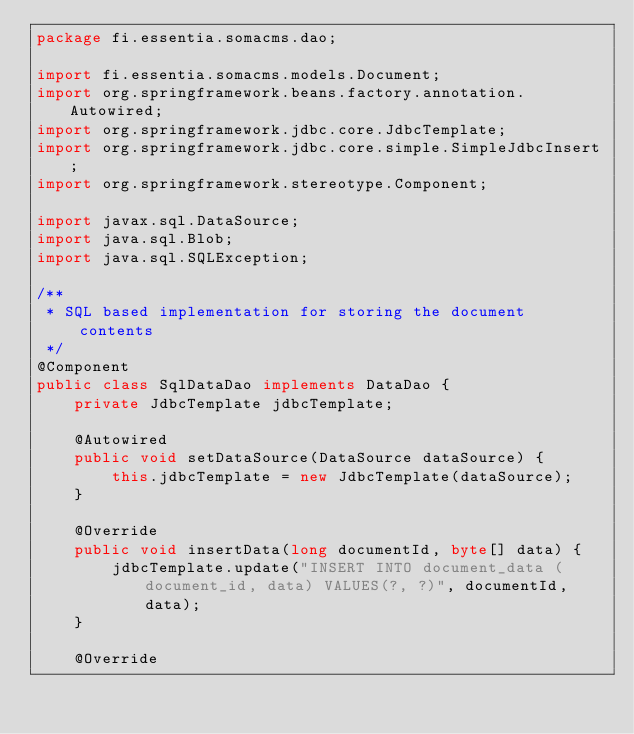Convert code to text. <code><loc_0><loc_0><loc_500><loc_500><_Java_>package fi.essentia.somacms.dao;

import fi.essentia.somacms.models.Document;
import org.springframework.beans.factory.annotation.Autowired;
import org.springframework.jdbc.core.JdbcTemplate;
import org.springframework.jdbc.core.simple.SimpleJdbcInsert;
import org.springframework.stereotype.Component;

import javax.sql.DataSource;
import java.sql.Blob;
import java.sql.SQLException;

/**
 * SQL based implementation for storing the document contents
 */
@Component
public class SqlDataDao implements DataDao {
    private JdbcTemplate jdbcTemplate;

    @Autowired
    public void setDataSource(DataSource dataSource) {
        this.jdbcTemplate = new JdbcTemplate(dataSource);
    }

    @Override
    public void insertData(long documentId, byte[] data) {
        jdbcTemplate.update("INSERT INTO document_data (document_id, data) VALUES(?, ?)", documentId, data);
    }

    @Override</code> 